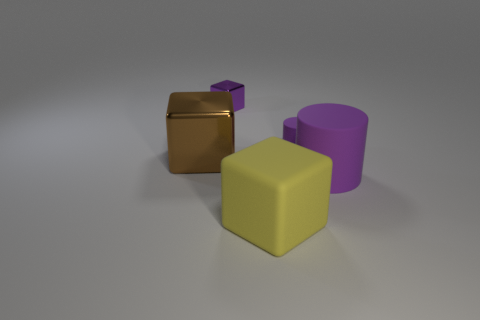Is the number of purple rubber cylinders behind the purple metallic block greater than the number of tiny matte cylinders that are in front of the matte block?
Ensure brevity in your answer.  No. Do the metallic thing that is in front of the small purple metallic cube and the large rubber thing that is in front of the big purple thing have the same color?
Provide a succinct answer. No. What is the shape of the yellow matte thing that is the same size as the brown metallic cube?
Your answer should be compact. Cube. Are there any rubber things of the same shape as the purple metallic object?
Make the answer very short. Yes. Are the tiny purple thing that is on the right side of the big yellow block and the large block that is right of the small block made of the same material?
Keep it short and to the point. Yes. What shape is the large matte object that is the same color as the small matte object?
Your answer should be very brief. Cylinder. How many things are the same material as the large brown block?
Give a very brief answer. 1. What is the color of the big rubber cylinder?
Make the answer very short. Purple. Does the purple rubber thing that is behind the brown thing have the same shape as the object to the left of the purple metal block?
Your response must be concise. No. The big cube behind the matte cube is what color?
Ensure brevity in your answer.  Brown. 